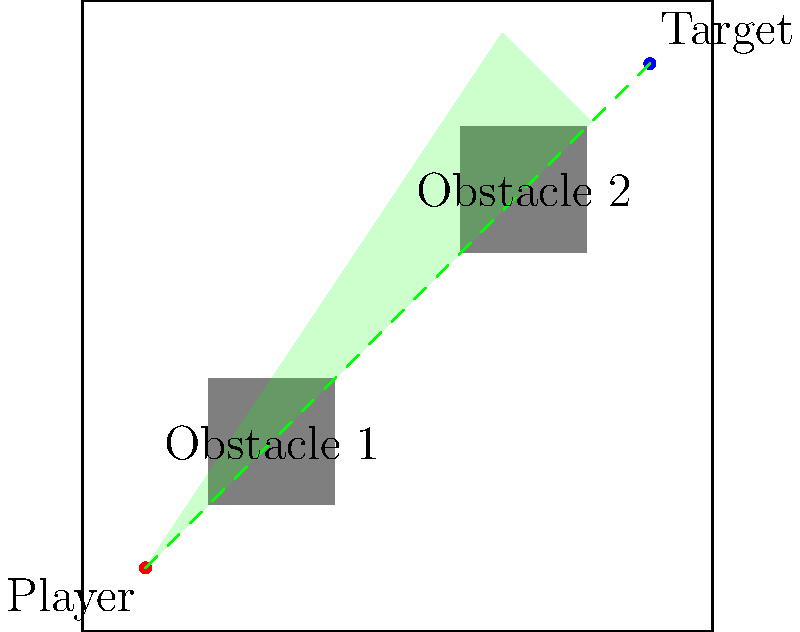In a first-person shooter game map, a player is positioned at coordinates (1,1) and wants to target an enemy at (9,9). Two obstacles are present on the map as shown. What is the approximate visible area (in square units) that the player can see, assuming a 90-degree field of view and ignoring the effects of the obstacles? To solve this problem, we'll follow these steps:

1. Identify the given information:
   - Player position: (1,1)
   - Target position: (9,9)
   - Field of view: 90 degrees

2. Calculate the direction vector from player to target:
   $\vec{v} = (9-1, 9-1) = (8, 8)$

3. Normalize the direction vector:
   $\|\vec{v}\| = \sqrt{8^2 + 8^2} = 8\sqrt{2}$
   $\vec{v}_\text{normalized} = (\frac{8}{8\sqrt{2}}, \frac{8}{8\sqrt{2}}) = (\frac{1}{\sqrt{2}}, \frac{1}{\sqrt{2}})$

4. Calculate the perpendicular vectors for the edges of the field of view:
   Left edge: $\vec{v}_\text{left} = (\frac{1}{\sqrt{2}}, -\frac{1}{\sqrt{2}})$
   Right edge: $\vec{v}_\text{right} = (\frac{1}{\sqrt{2}}, \frac{1}{\sqrt{2}})$

5. Determine the visible area:
   The visible area forms a circular sector with a radius of 9 units (distance to the farthest corner) and a central angle of 90 degrees.

6. Calculate the area of the circular sector:
   $A = \frac{1}{2} r^2 \theta$, where $r$ is the radius and $\theta$ is the central angle in radians.
   $\theta = 90° = \frac{\pi}{2}$ radians
   $A = \frac{1}{2} \cdot 9^2 \cdot \frac{\pi}{2} = \frac{81\pi}{4} \approx 63.62$ square units

Note: This calculation ignores the effects of obstacles, which would reduce the actual visible area in the game.
Answer: Approximately 63.62 square units 